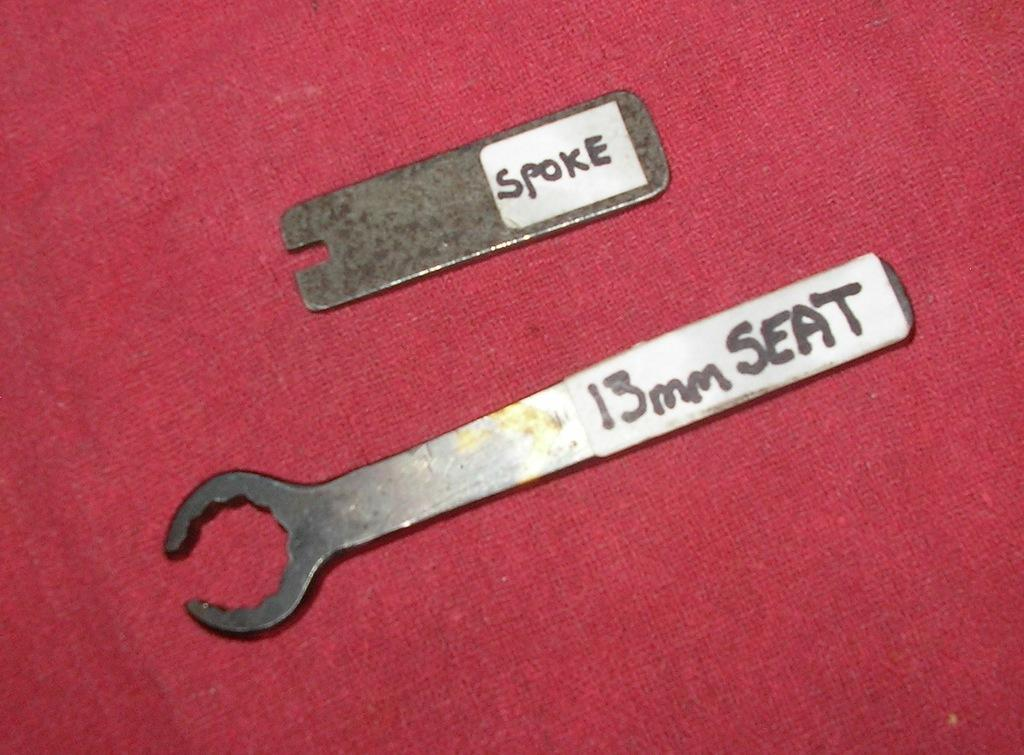What type of objects are in the image? There are two metal objects in the image. What is the color of the surface on which the metal objects are placed? The metal objects are on a red surface. Are there any additional decorations or items on the red surface? Yes, there are stickers on the red surface. What type of meat is being cooked on the hydrant in the image? There is no hydrant or meat present in the image. 